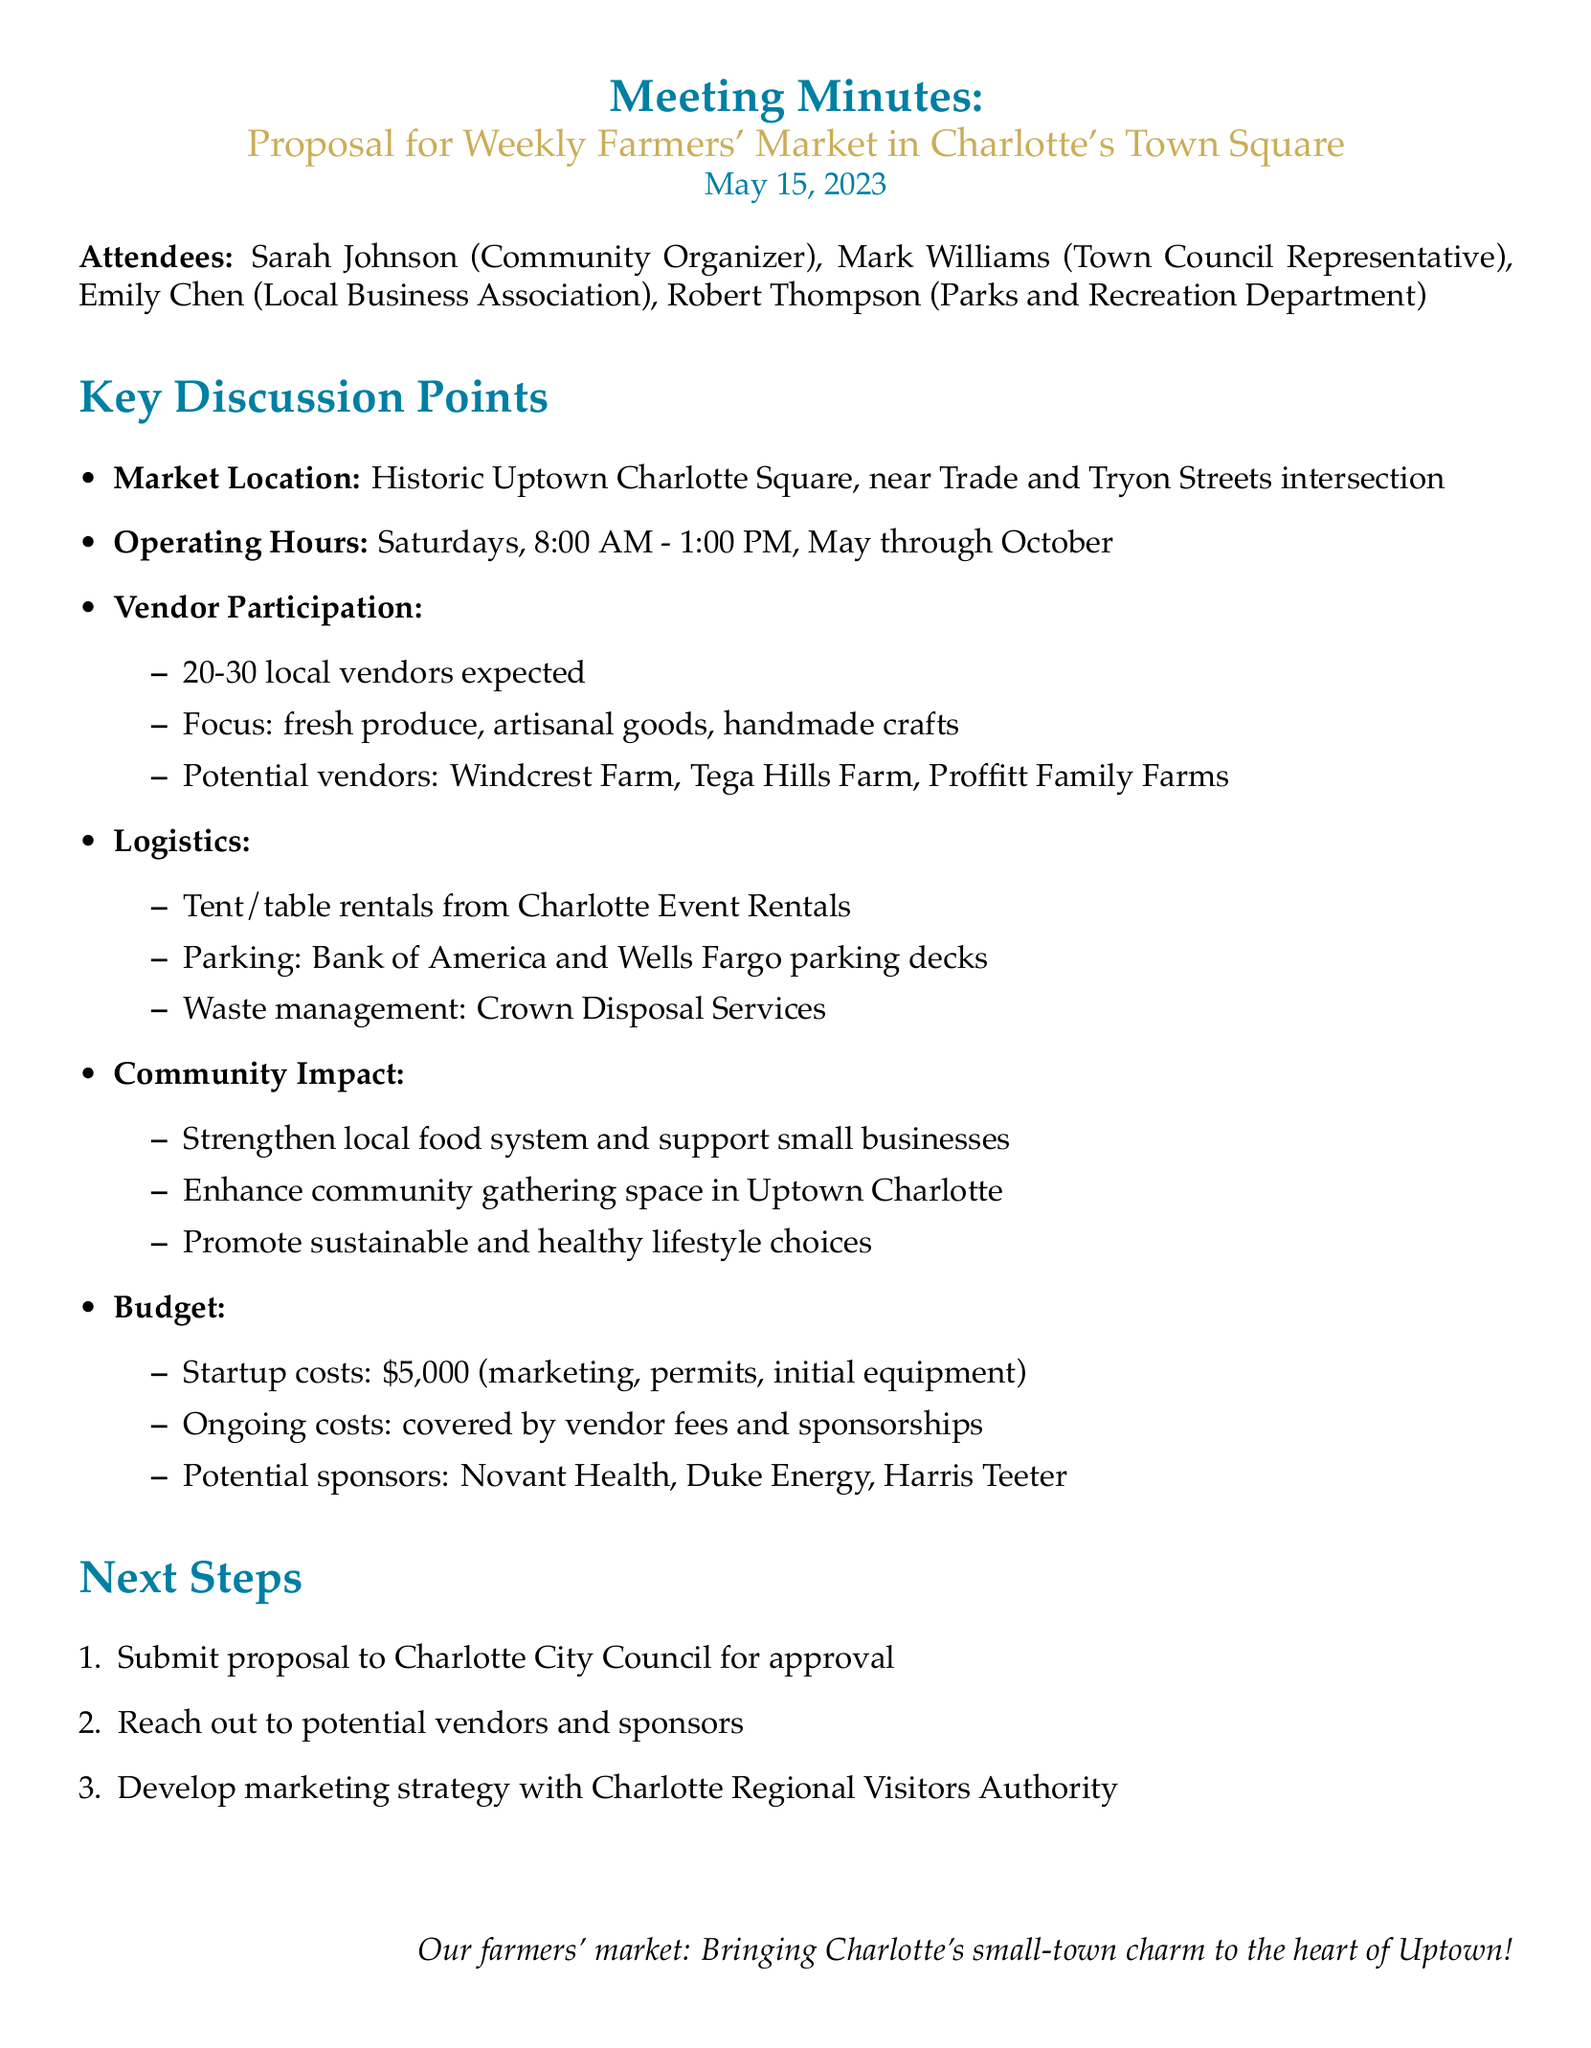What is the proposed location for the farmers' market? The proposed location is stated as Historic Uptown Charlotte Square, which is specified in the agenda.
Answer: Historic Uptown Charlotte Square When will the farmers' market operate? The operating hours detail that the market will be on Saturdays from 8:00 AM to 1:00 PM, from May through October.
Answer: Saturdays from 8:00 AM to 1:00 PM, May through October How many vendors are expected to participate? The document details that the expected participation is between 20 to 30 local vendors.
Answer: 20-30 local vendors What is the estimated startup cost for the farmers' market? The budget section specifies the estimated startup costs, which include marketing, permits, and initial equipment.
Answer: $5,000 Which two banks are mentioned for parking arrangements? The logistics section lists these banks, indicating where parking arrangements will occur for the market attendees.
Answer: Bank of America and Wells Fargo What kind of goods will the market focus on? The vendor participation details describe the market's focus, indicating the types of items that will be available.
Answer: Fresh produce, artisanal goods, handmade crafts What is one goal of the farmers' market mentioned in the community impact section? The community impact section includes various goals aimed at enhancing the community and supporting local businesses.
Answer: Strengthen local food system What is the next step after submitting the proposal? The next steps outlined in the document list the actions to be taken following the proposal submission to the council.
Answer: Reach out to potential vendors and sponsors 